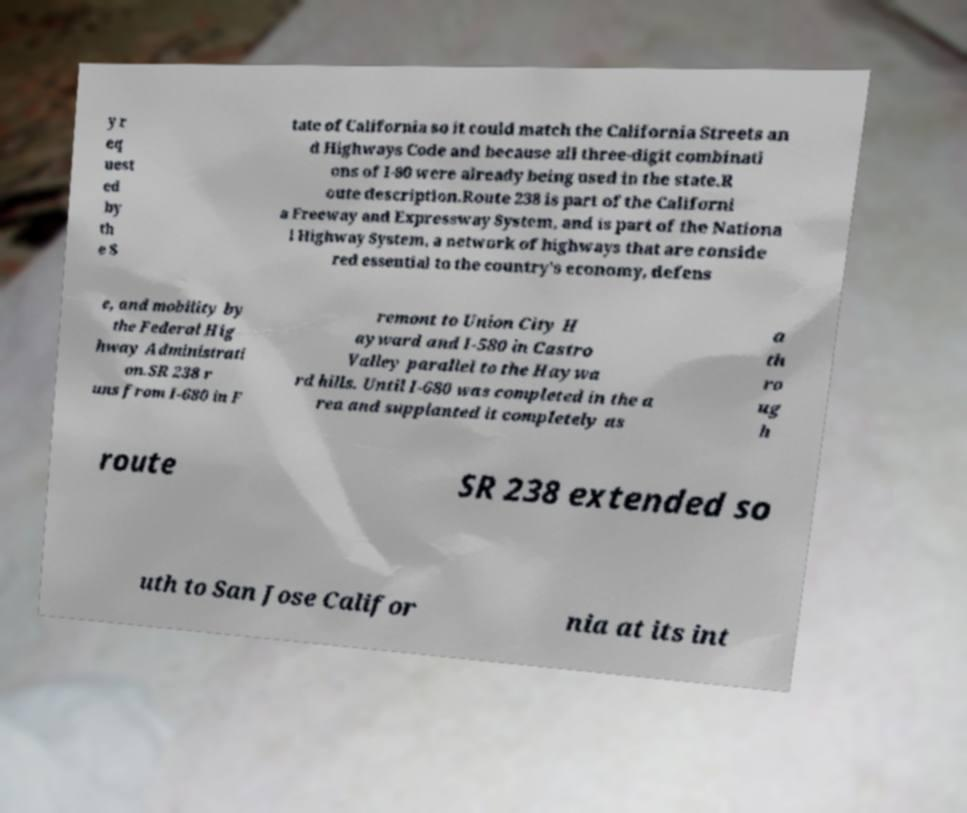Can you read and provide the text displayed in the image?This photo seems to have some interesting text. Can you extract and type it out for me? y r eq uest ed by th e S tate of California so it could match the California Streets an d Highways Code and because all three-digit combinati ons of I-80 were already being used in the state.R oute description.Route 238 is part of the Californi a Freeway and Expressway System, and is part of the Nationa l Highway System, a network of highways that are conside red essential to the country's economy, defens e, and mobility by the Federal Hig hway Administrati on.SR 238 r uns from I-680 in F remont to Union City H ayward and I-580 in Castro Valley parallel to the Haywa rd hills. Until I-680 was completed in the a rea and supplanted it completely as a th ro ug h route SR 238 extended so uth to San Jose Califor nia at its int 